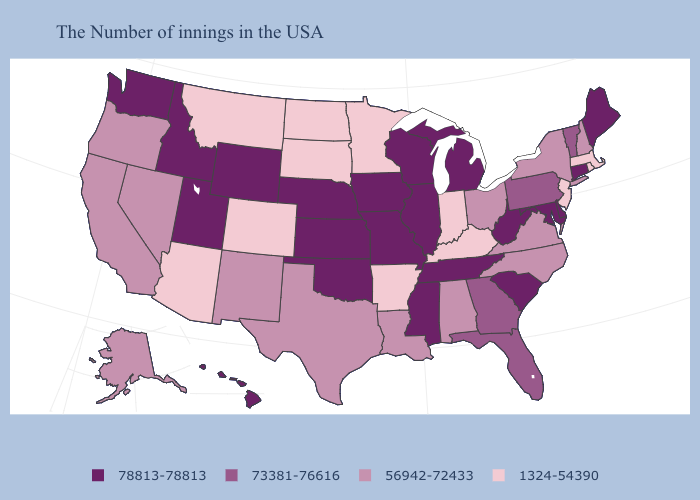What is the highest value in the West ?
Quick response, please. 78813-78813. What is the highest value in the USA?
Keep it brief. 78813-78813. Name the states that have a value in the range 56942-72433?
Answer briefly. New Hampshire, New York, Virginia, North Carolina, Ohio, Alabama, Louisiana, Texas, New Mexico, Nevada, California, Oregon, Alaska. What is the highest value in the USA?
Be succinct. 78813-78813. Does the first symbol in the legend represent the smallest category?
Quick response, please. No. Name the states that have a value in the range 1324-54390?
Keep it brief. Massachusetts, Rhode Island, New Jersey, Kentucky, Indiana, Arkansas, Minnesota, South Dakota, North Dakota, Colorado, Montana, Arizona. Name the states that have a value in the range 56942-72433?
Answer briefly. New Hampshire, New York, Virginia, North Carolina, Ohio, Alabama, Louisiana, Texas, New Mexico, Nevada, California, Oregon, Alaska. Is the legend a continuous bar?
Answer briefly. No. What is the value of Minnesota?
Give a very brief answer. 1324-54390. Among the states that border Illinois , which have the highest value?
Be succinct. Wisconsin, Missouri, Iowa. What is the lowest value in the USA?
Concise answer only. 1324-54390. Is the legend a continuous bar?
Be succinct. No. What is the value of Louisiana?
Concise answer only. 56942-72433. Which states hav the highest value in the South?
Short answer required. Delaware, Maryland, South Carolina, West Virginia, Tennessee, Mississippi, Oklahoma. Which states hav the highest value in the MidWest?
Write a very short answer. Michigan, Wisconsin, Illinois, Missouri, Iowa, Kansas, Nebraska. 